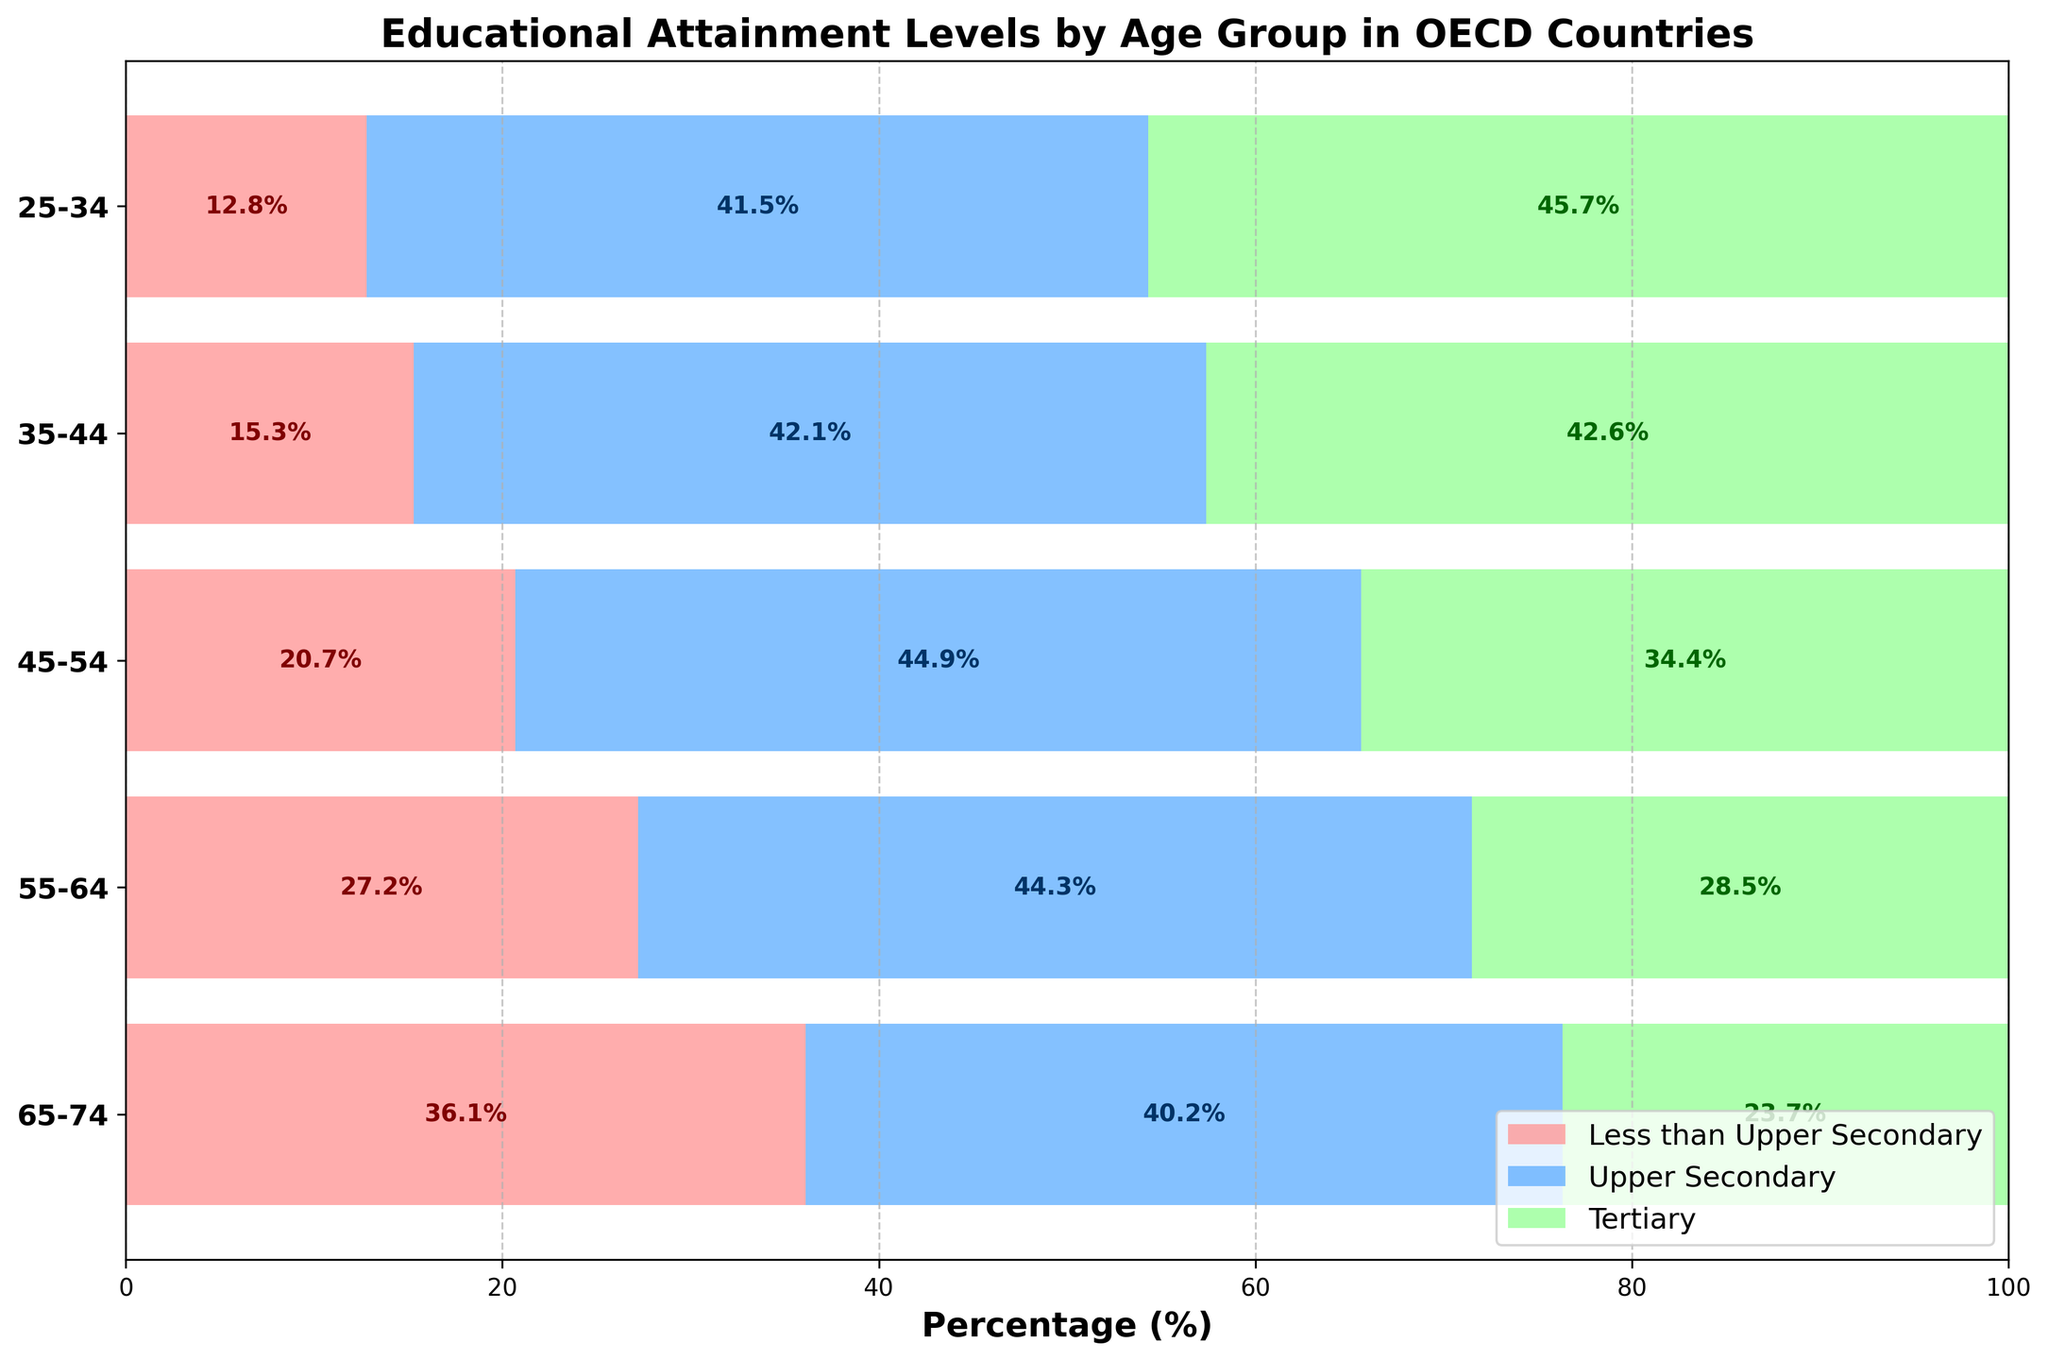What's the title of the figure? The title is typically located at the top of the figure. We can see the bold text at the top which reads 'Educational Attainment Levels by Age Group in OECD Countries'
Answer: Educational Attainment Levels by Age Group in OECD Countries What percentage of the 25-34 age group has a tertiary education? In the bar for the 25-34 age group, the section for tertiary education is labeled as 45.7%.
Answer: 45.7% Which age group has the highest percentage of people with less than upper secondary education? The highest bar section for 'Less than Upper Secondary' is in the 65-74 age group, showing 36.1%.
Answer: 65-74 with 36.1% What is the percentage of people aged 45-54 with an upper secondary education? In the 45-54 age group, the section for upper secondary is labeled as 44.9%.
Answer: 44.9% Compare the tertiary education percentage between the age groups 25-34 and 55-64. Which one is higher? The tertiary education percentage for the 25-34 age group is 45.7%, while for the 55-64 age group, it is 28.5%. 45.7% is higher.
Answer: 25-34 with 45.7% What is the total percentage of people aged 55-64 with at least an upper secondary education? To calculate this, add the percentages for upper secondary and tertiary education for the 55-64 age group: 44.3% + 28.5% = 72.8%.
Answer: 72.8% How does the percentage of people with less than upper secondary education change from the 25-34 age group to the 65-74 age group? The percentage increases from 12.8% in the 25-34 age group to 36.1% in the 65-74 age group. To find the increase: 36.1% - 12.8% = 23.3%.
Answer: It increases by 23.3% What age group has the smallest percentage of people with less than upper secondary education? The smallest section for 'Less than Upper Secondary' is in the 25-34 age group, showing 12.8%.
Answer: 25-34 with 12.8% What is the difference in percentage points between the highest and lowest age groups in tertiary education? The highest percentage is in the 25-34 age group at 45.7%, and the lowest is in the 65-74 age group at 23.7%. The difference is: 45.7% - 23.7% = 22 percentage points.
Answer: 22 percentage points 